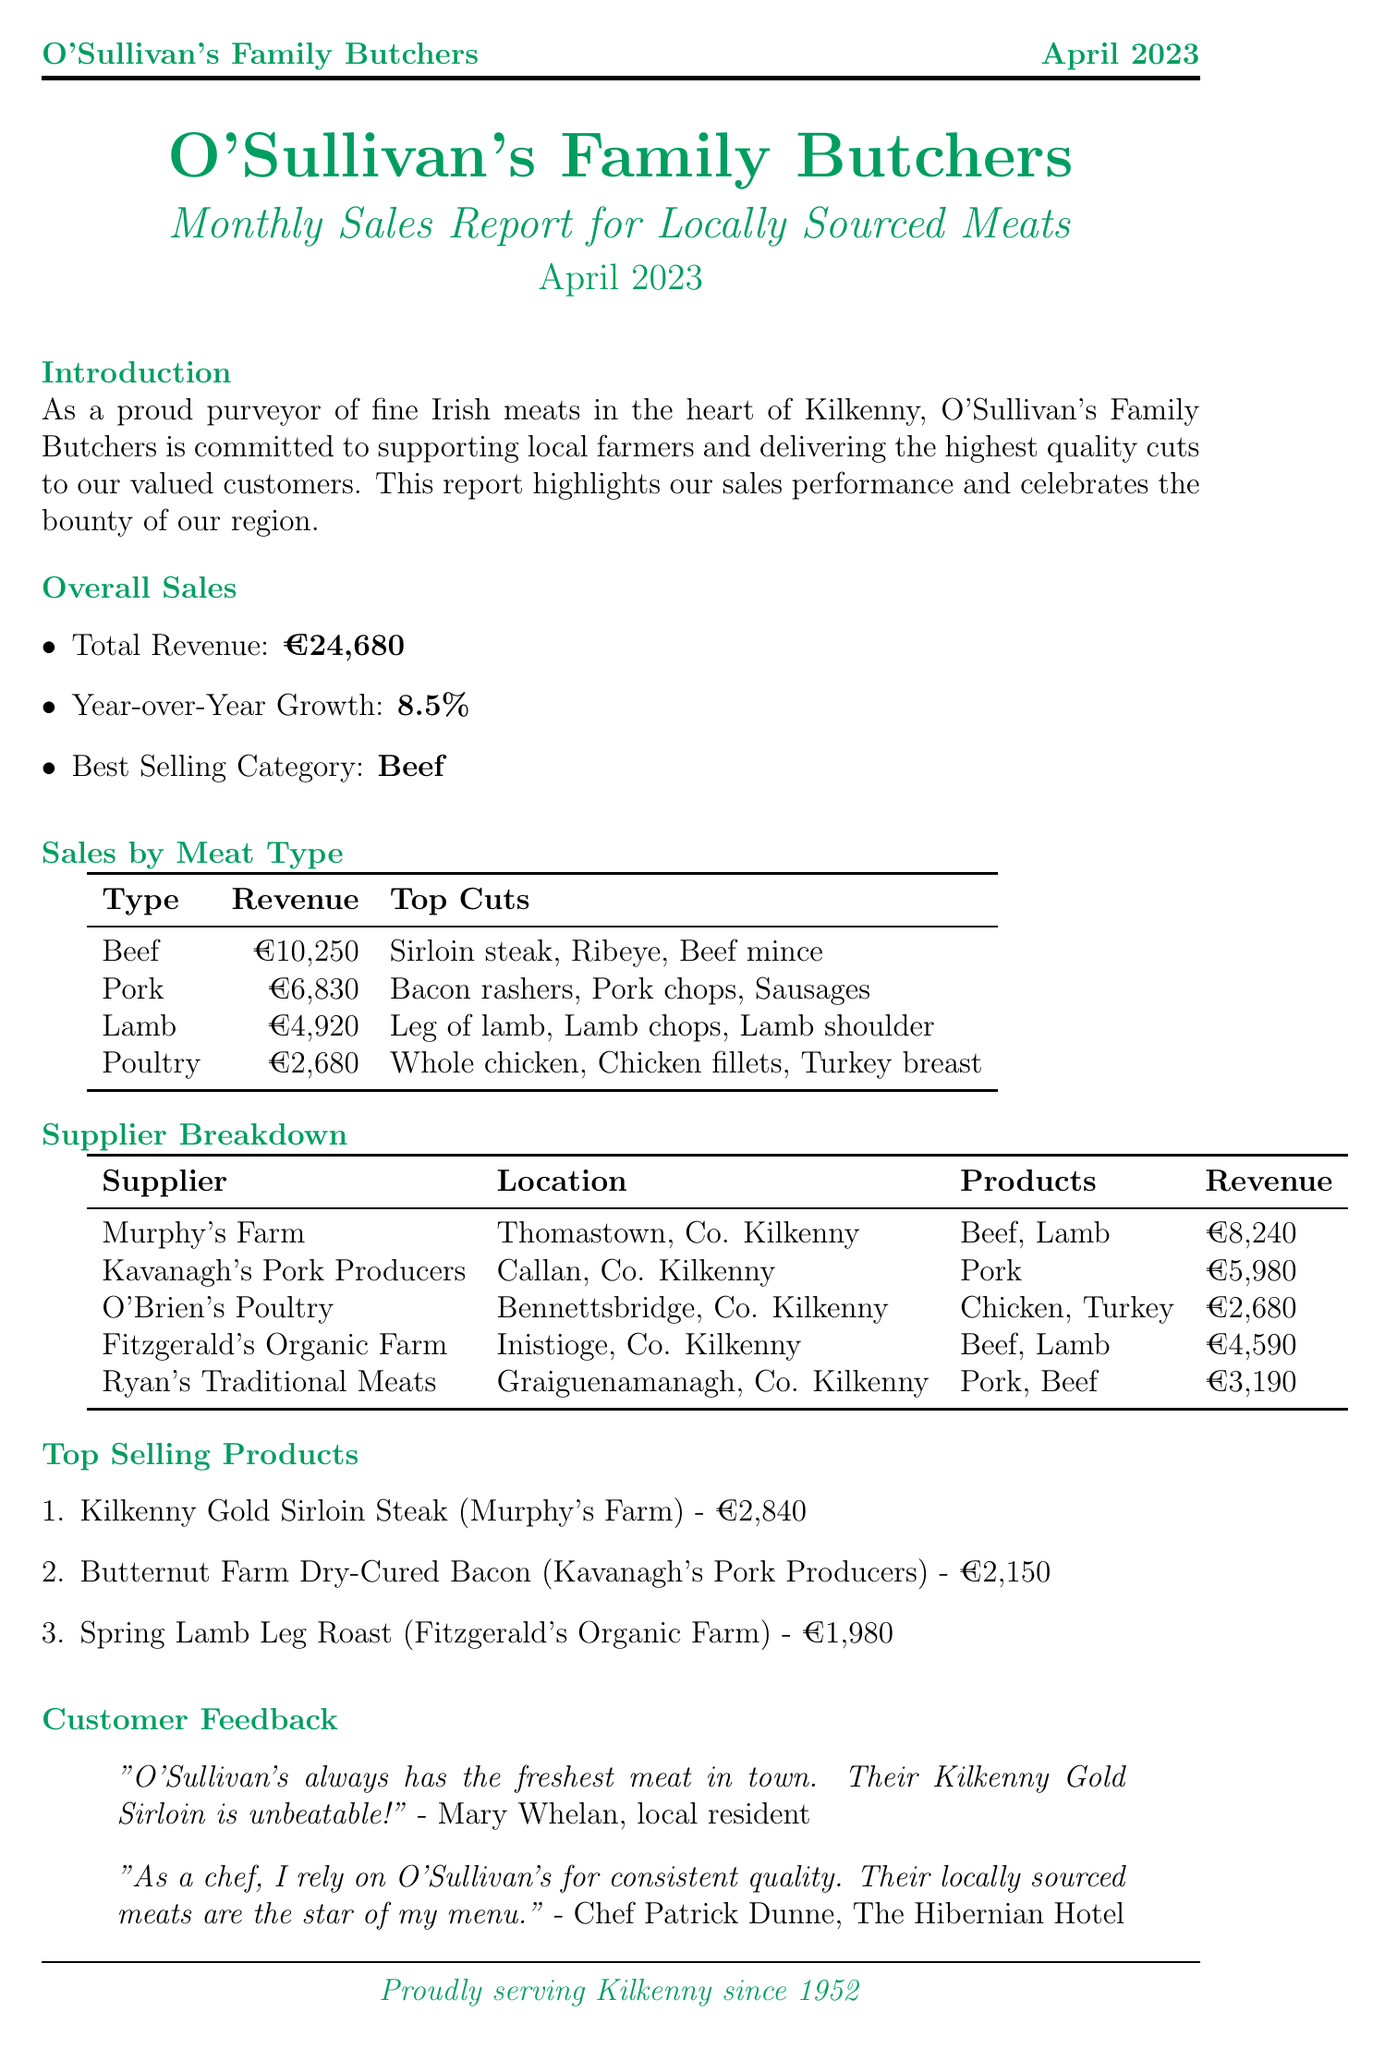what is the best selling category? The best selling category is specified under overall sales in the document.
Answer: Beef what was the total revenue for April 2023? The total revenue is detailed in the overall sales section of the report.
Answer: €24,680 who is the supplier of the top selling product? The supplier of the top selling product is mentioned with the product in the top selling products section.
Answer: Murphy's Farm how much revenue did Kavanagh's Pork Producers generate? The revenue generated by Kavanagh's Pork Producers is listed in the supplier breakdown.
Answer: €5,980 what is the year-over-year growth percentage? The year-over-year growth percentage is found in the overall sales section of the report.
Answer: 8.5% which product is the top selling in the poultry category? The report lists the top cuts for each meat type, including poultry, in the sales by meat type section.
Answer: Whole chicken what location is Murphy's Farm based in? The location of Murphy's Farm is mentioned in the supplier breakdown.
Answer: Thomastown, Co. Kilkenny what is the starting date of the Summer BBQ Special promotion? The starting date of the Summer BBQ Special is outlined in the upcoming promotions section.
Answer: May 1, 2023 